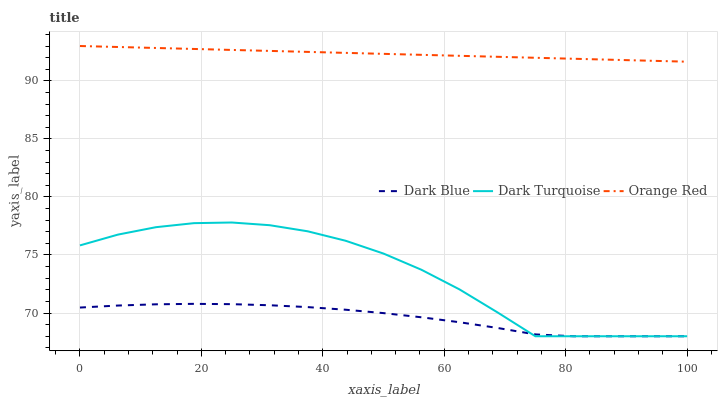Does Dark Blue have the minimum area under the curve?
Answer yes or no. Yes. Does Orange Red have the maximum area under the curve?
Answer yes or no. Yes. Does Dark Turquoise have the minimum area under the curve?
Answer yes or no. No. Does Dark Turquoise have the maximum area under the curve?
Answer yes or no. No. Is Orange Red the smoothest?
Answer yes or no. Yes. Is Dark Turquoise the roughest?
Answer yes or no. Yes. Is Dark Turquoise the smoothest?
Answer yes or no. No. Is Orange Red the roughest?
Answer yes or no. No. Does Dark Blue have the lowest value?
Answer yes or no. Yes. Does Orange Red have the lowest value?
Answer yes or no. No. Does Orange Red have the highest value?
Answer yes or no. Yes. Does Dark Turquoise have the highest value?
Answer yes or no. No. Is Dark Turquoise less than Orange Red?
Answer yes or no. Yes. Is Orange Red greater than Dark Blue?
Answer yes or no. Yes. Does Dark Turquoise intersect Dark Blue?
Answer yes or no. Yes. Is Dark Turquoise less than Dark Blue?
Answer yes or no. No. Is Dark Turquoise greater than Dark Blue?
Answer yes or no. No. Does Dark Turquoise intersect Orange Red?
Answer yes or no. No. 